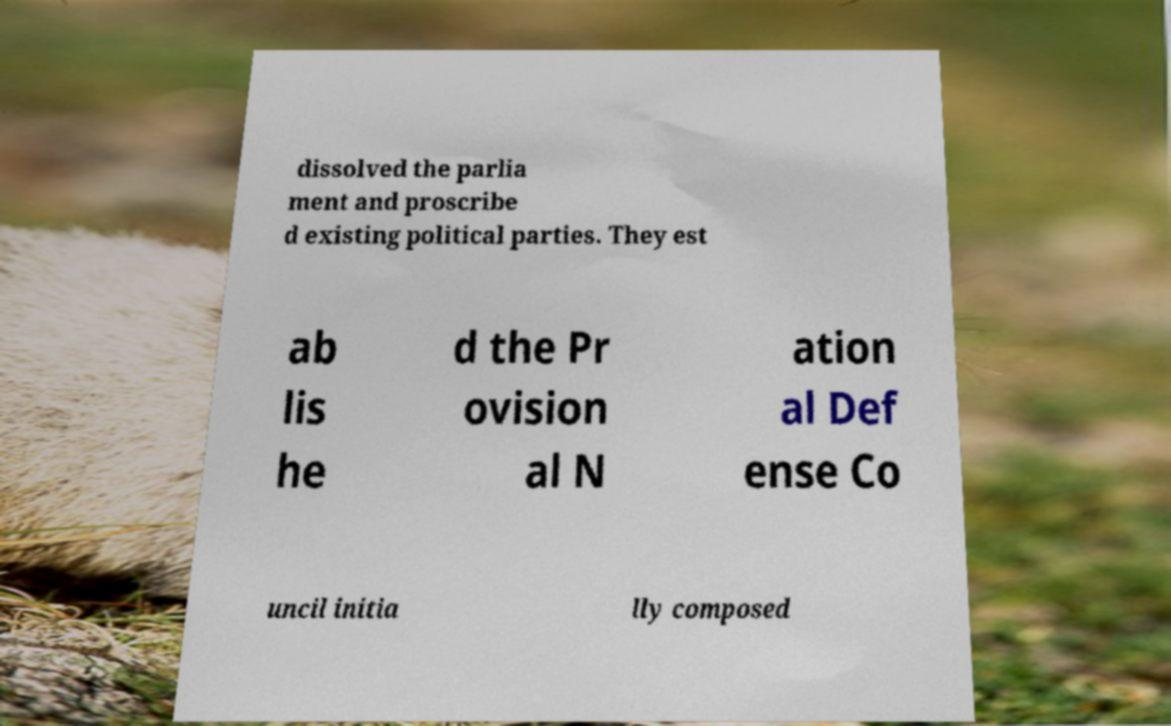For documentation purposes, I need the text within this image transcribed. Could you provide that? dissolved the parlia ment and proscribe d existing political parties. They est ab lis he d the Pr ovision al N ation al Def ense Co uncil initia lly composed 